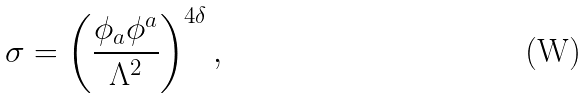<formula> <loc_0><loc_0><loc_500><loc_500>\sigma = \left ( \frac { \phi _ { a } \phi ^ { a } } { \Lambda ^ { 2 } } \right ) ^ { 4 \delta } ,</formula> 